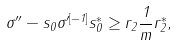Convert formula to latex. <formula><loc_0><loc_0><loc_500><loc_500>\sigma ^ { \prime \prime } - s _ { 0 } \sigma ^ { \prime [ - 1 ] } s _ { 0 } ^ { * } \geq r _ { 2 } \frac { 1 } { m } r _ { 2 } ^ { * } ,</formula> 